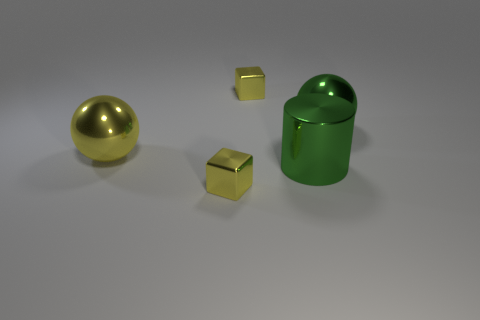How many large balls are there?
Your answer should be compact. 2. There is a yellow thing that is the same size as the green ball; what is its material?
Your answer should be very brief. Metal. Are there any metal objects of the same size as the cylinder?
Your answer should be compact. Yes. Does the metal thing that is on the right side of the large cylinder have the same color as the large metallic cylinder that is left of the large green shiny sphere?
Ensure brevity in your answer.  Yes. What number of rubber objects are big green spheres or big yellow balls?
Your answer should be very brief. 0. What number of big yellow shiny things are on the right side of the large green metallic thing that is in front of the green shiny sphere to the right of the yellow shiny sphere?
Offer a terse response. 0. What size is the green thing that is made of the same material as the big green ball?
Ensure brevity in your answer.  Large. What number of metal cubes have the same color as the large cylinder?
Offer a terse response. 0. There is a green thing that is behind the cylinder; is it the same size as the large yellow metal sphere?
Offer a very short reply. Yes. The shiny object that is both left of the big green metallic cylinder and in front of the large yellow ball is what color?
Your answer should be compact. Yellow. 